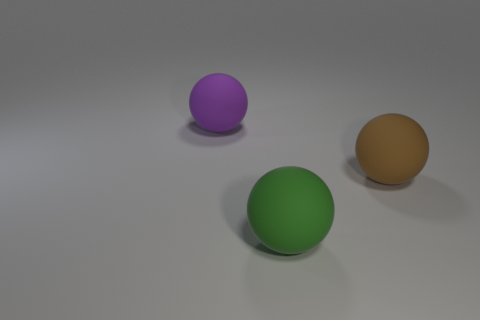Add 3 large blue metal things. How many objects exist? 6 Subtract all cyan spheres. Subtract all red cylinders. How many spheres are left? 3 Add 2 big green matte objects. How many big green matte objects are left? 3 Add 1 big green spheres. How many big green spheres exist? 2 Subtract 0 brown cubes. How many objects are left? 3 Subtract all cyan rubber cylinders. Subtract all big green balls. How many objects are left? 2 